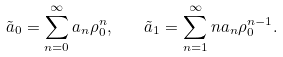<formula> <loc_0><loc_0><loc_500><loc_500>\tilde { a } _ { 0 } = \sum _ { n = 0 } ^ { \infty } a _ { n } \rho _ { 0 } ^ { n } , \quad \tilde { a } _ { 1 } = \sum _ { n = 1 } ^ { \infty } n a _ { n } \rho _ { 0 } ^ { n - 1 } .</formula> 